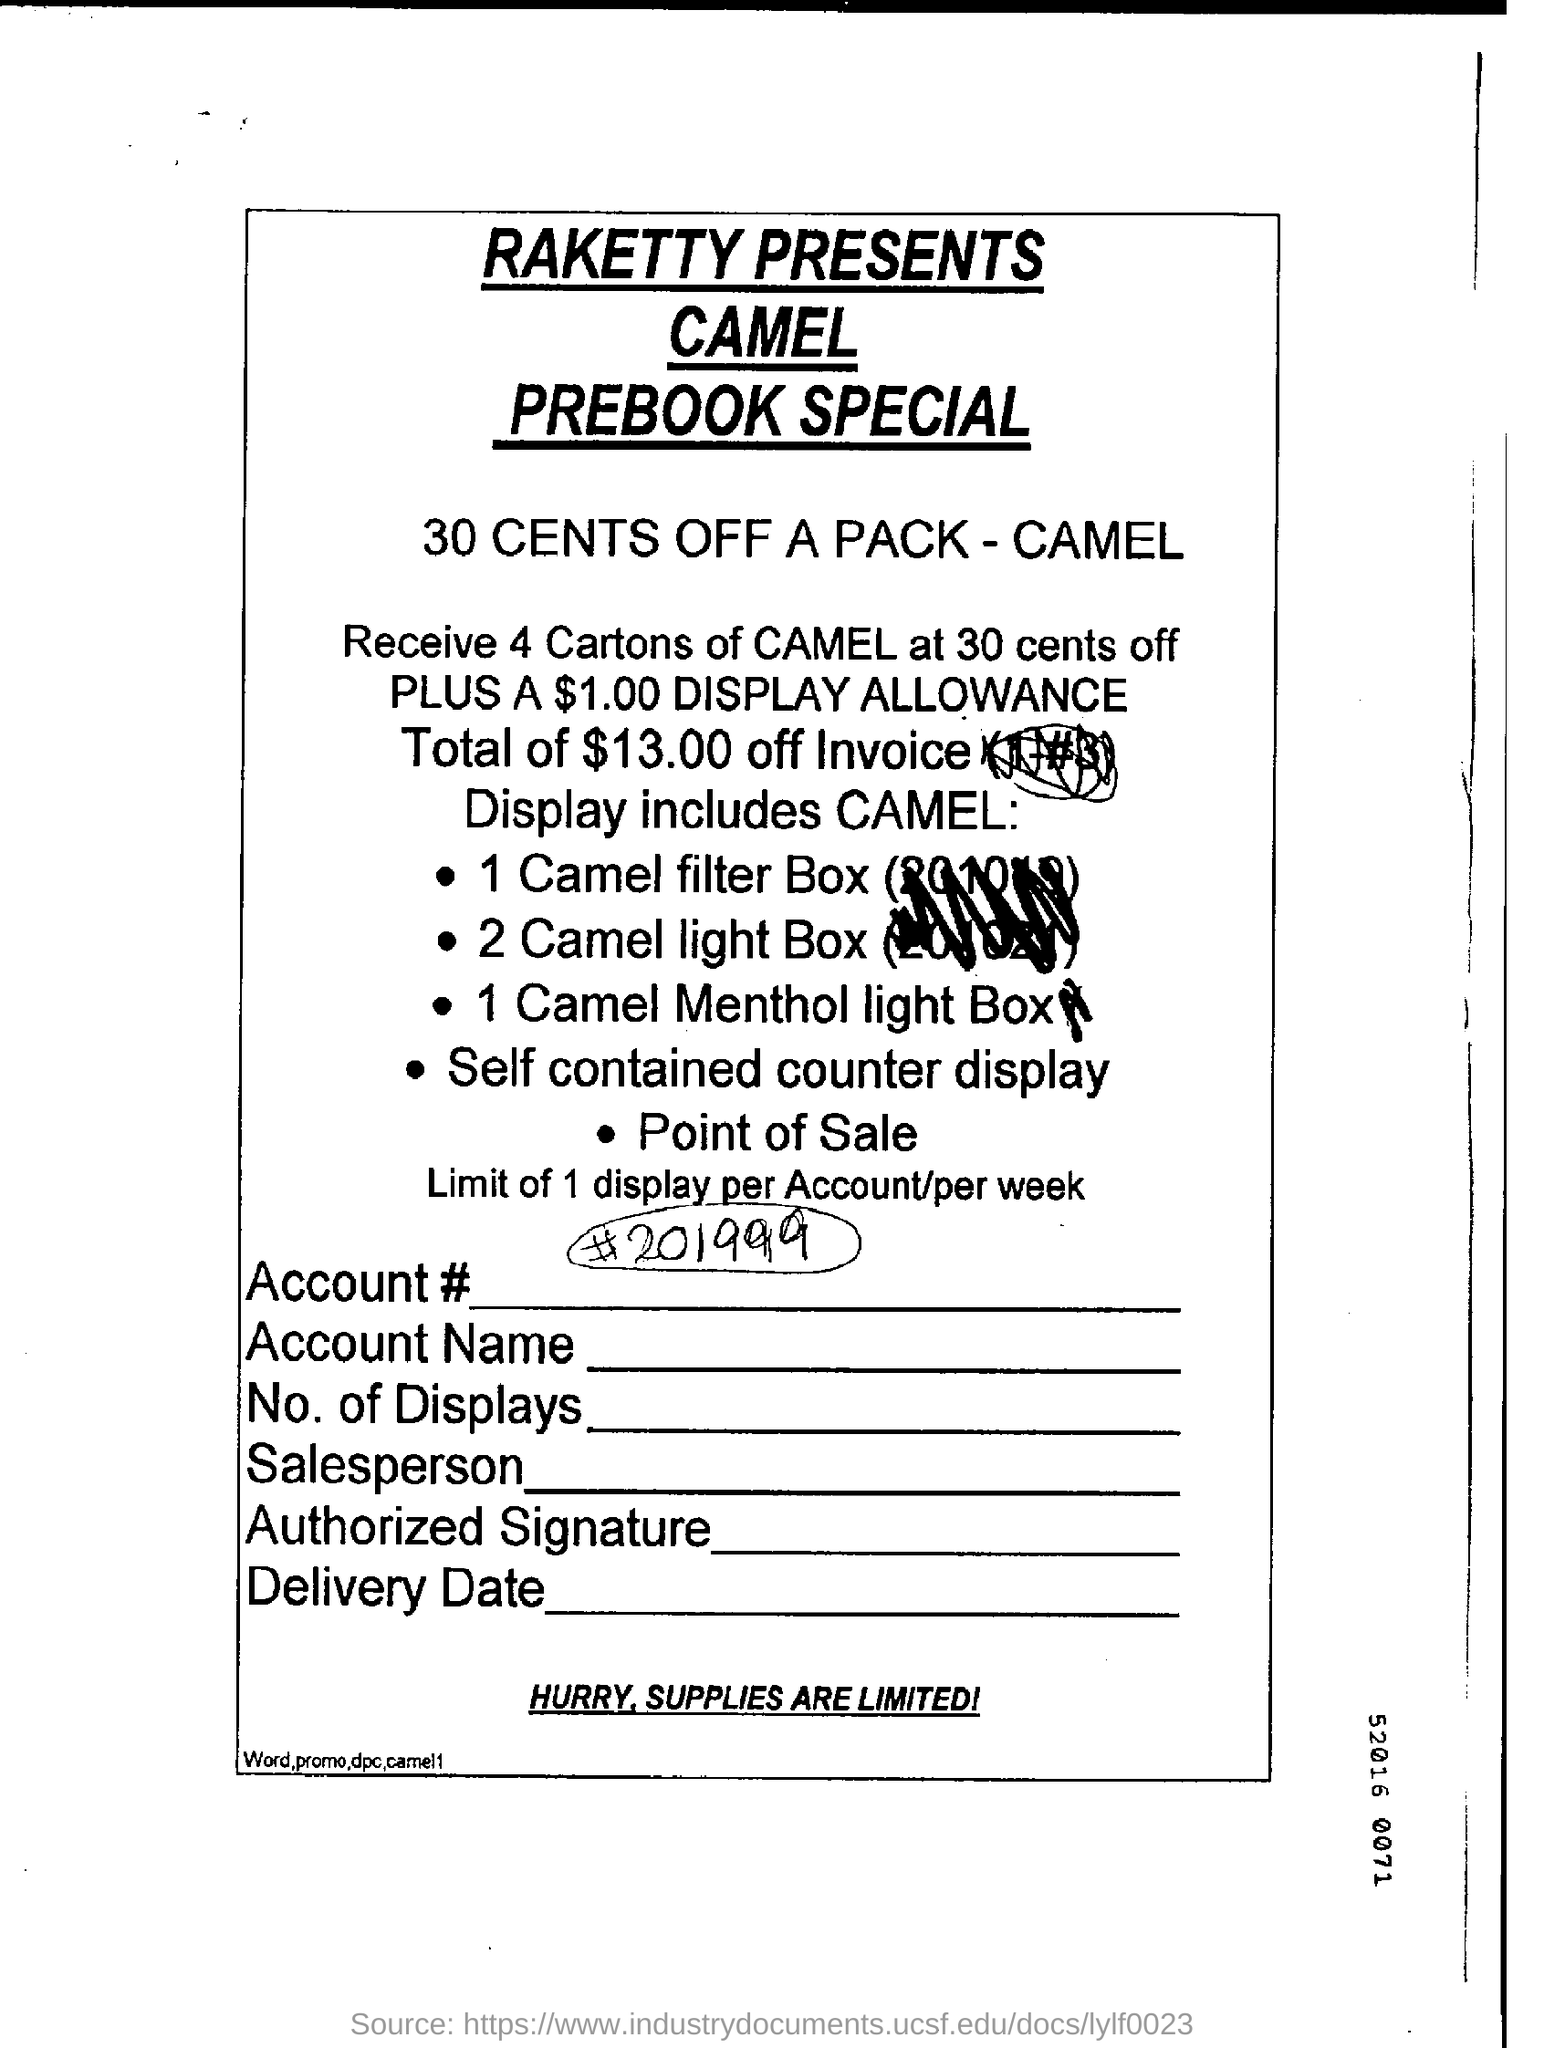Indicate a few pertinent items in this graphic. I received a display allowance of $1.00. Raketty will be presenting a special edition of the Camel prebook. 